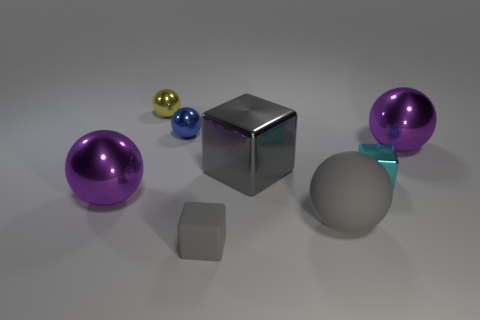There is a large purple shiny object on the left side of the purple shiny ball right of the large rubber thing; is there a small metal ball that is on the left side of it?
Ensure brevity in your answer.  No. What is the shape of the big metal thing that is the same color as the small rubber cube?
Give a very brief answer. Cube. How many large objects are either purple shiny spheres or gray things?
Make the answer very short. 4. Do the big purple metallic thing that is left of the blue metal thing and the tiny yellow thing have the same shape?
Provide a succinct answer. Yes. Is the number of tiny cyan shiny cubes less than the number of purple shiny things?
Your answer should be compact. Yes. Is there anything else that is the same color as the large block?
Your response must be concise. Yes. The small object that is to the left of the blue metallic object has what shape?
Provide a succinct answer. Sphere. Is the color of the small rubber object the same as the large rubber thing that is behind the tiny matte block?
Make the answer very short. Yes. Is the number of big purple shiny balls to the left of the small yellow thing the same as the number of purple balls behind the blue object?
Offer a very short reply. No. How many other things are the same size as the yellow thing?
Your answer should be compact. 3. 